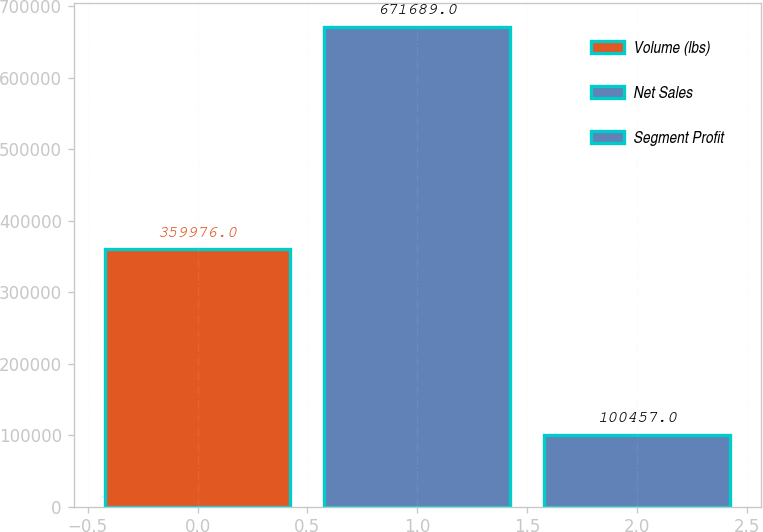<chart> <loc_0><loc_0><loc_500><loc_500><bar_chart><fcel>Volume (lbs)<fcel>Net Sales<fcel>Segment Profit<nl><fcel>359976<fcel>671689<fcel>100457<nl></chart> 